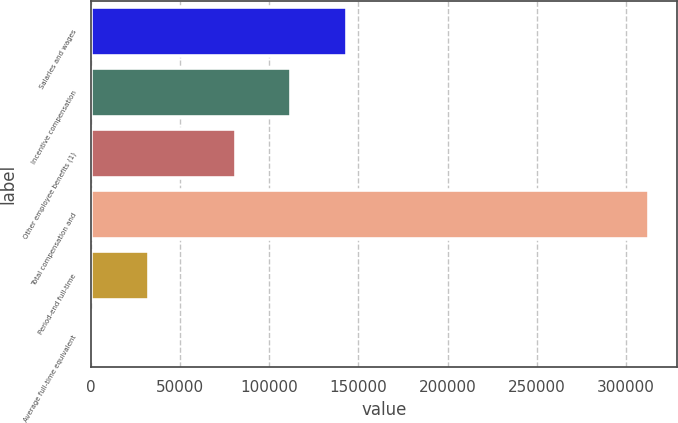Convert chart to OTSL. <chart><loc_0><loc_0><loc_500><loc_500><bar_chart><fcel>Salaries and wages<fcel>Incentive compensation<fcel>Other employee benefits (1)<fcel>Total compensation and<fcel>Period-end full-time<fcel>Average full-time equivalent<nl><fcel>143377<fcel>112218<fcel>81059<fcel>313043<fcel>32610.2<fcel>1451<nl></chart> 